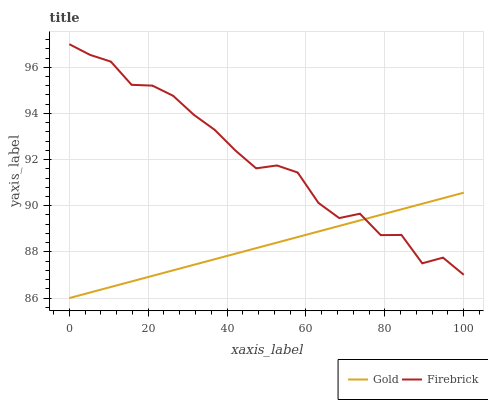Does Gold have the minimum area under the curve?
Answer yes or no. Yes. Does Firebrick have the maximum area under the curve?
Answer yes or no. Yes. Does Gold have the maximum area under the curve?
Answer yes or no. No. Is Gold the smoothest?
Answer yes or no. Yes. Is Firebrick the roughest?
Answer yes or no. Yes. Is Gold the roughest?
Answer yes or no. No. Does Gold have the lowest value?
Answer yes or no. Yes. Does Firebrick have the highest value?
Answer yes or no. Yes. Does Gold have the highest value?
Answer yes or no. No. Does Firebrick intersect Gold?
Answer yes or no. Yes. Is Firebrick less than Gold?
Answer yes or no. No. Is Firebrick greater than Gold?
Answer yes or no. No. 